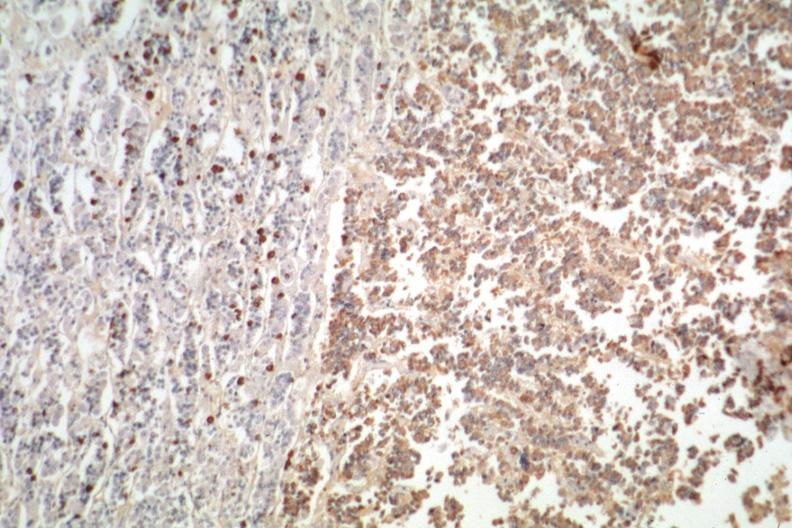does this image show immunostain for growth hormone stain is positive?
Answer the question using a single word or phrase. Yes 